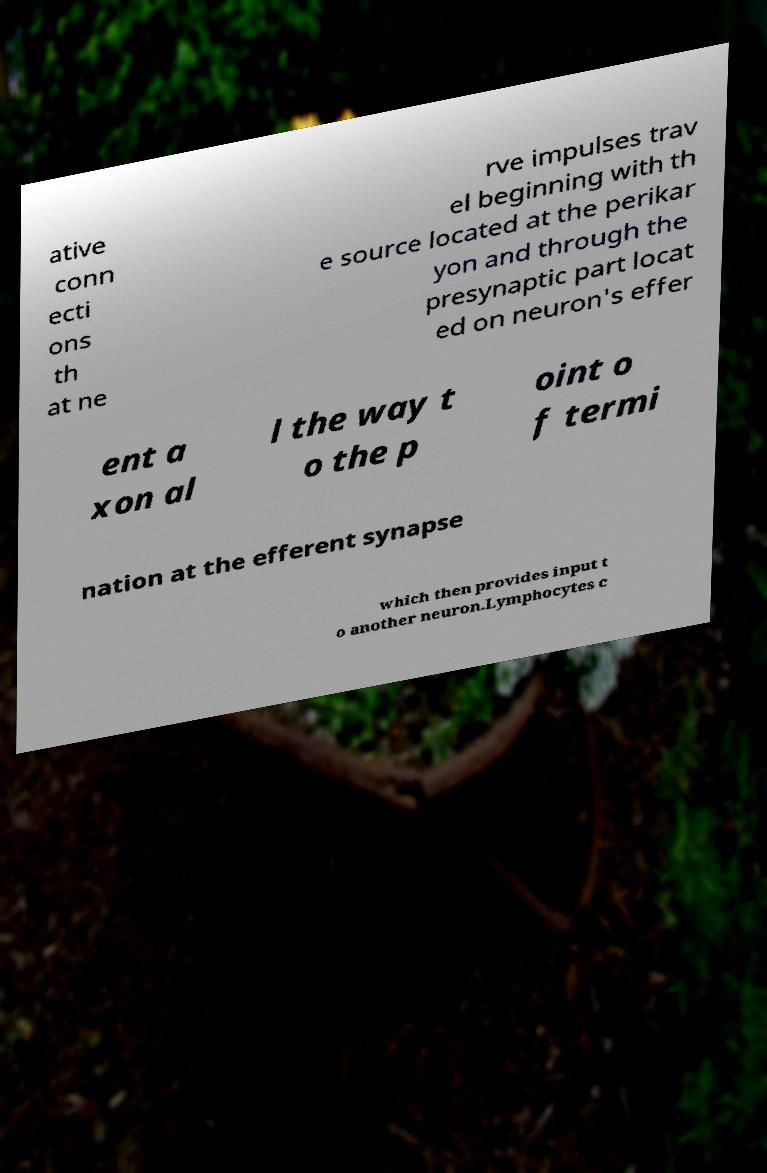Can you accurately transcribe the text from the provided image for me? ative conn ecti ons th at ne rve impulses trav el beginning with th e source located at the perikar yon and through the presynaptic part locat ed on neuron's effer ent a xon al l the way t o the p oint o f termi nation at the efferent synapse which then provides input t o another neuron.Lymphocytes c 